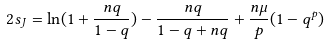<formula> <loc_0><loc_0><loc_500><loc_500>2 s _ { J } = \ln ( 1 + \frac { n q } { 1 - q } ) - \frac { n q } { 1 - q + n q } + \frac { n \mu } { p } ( 1 - q ^ { p } )</formula> 